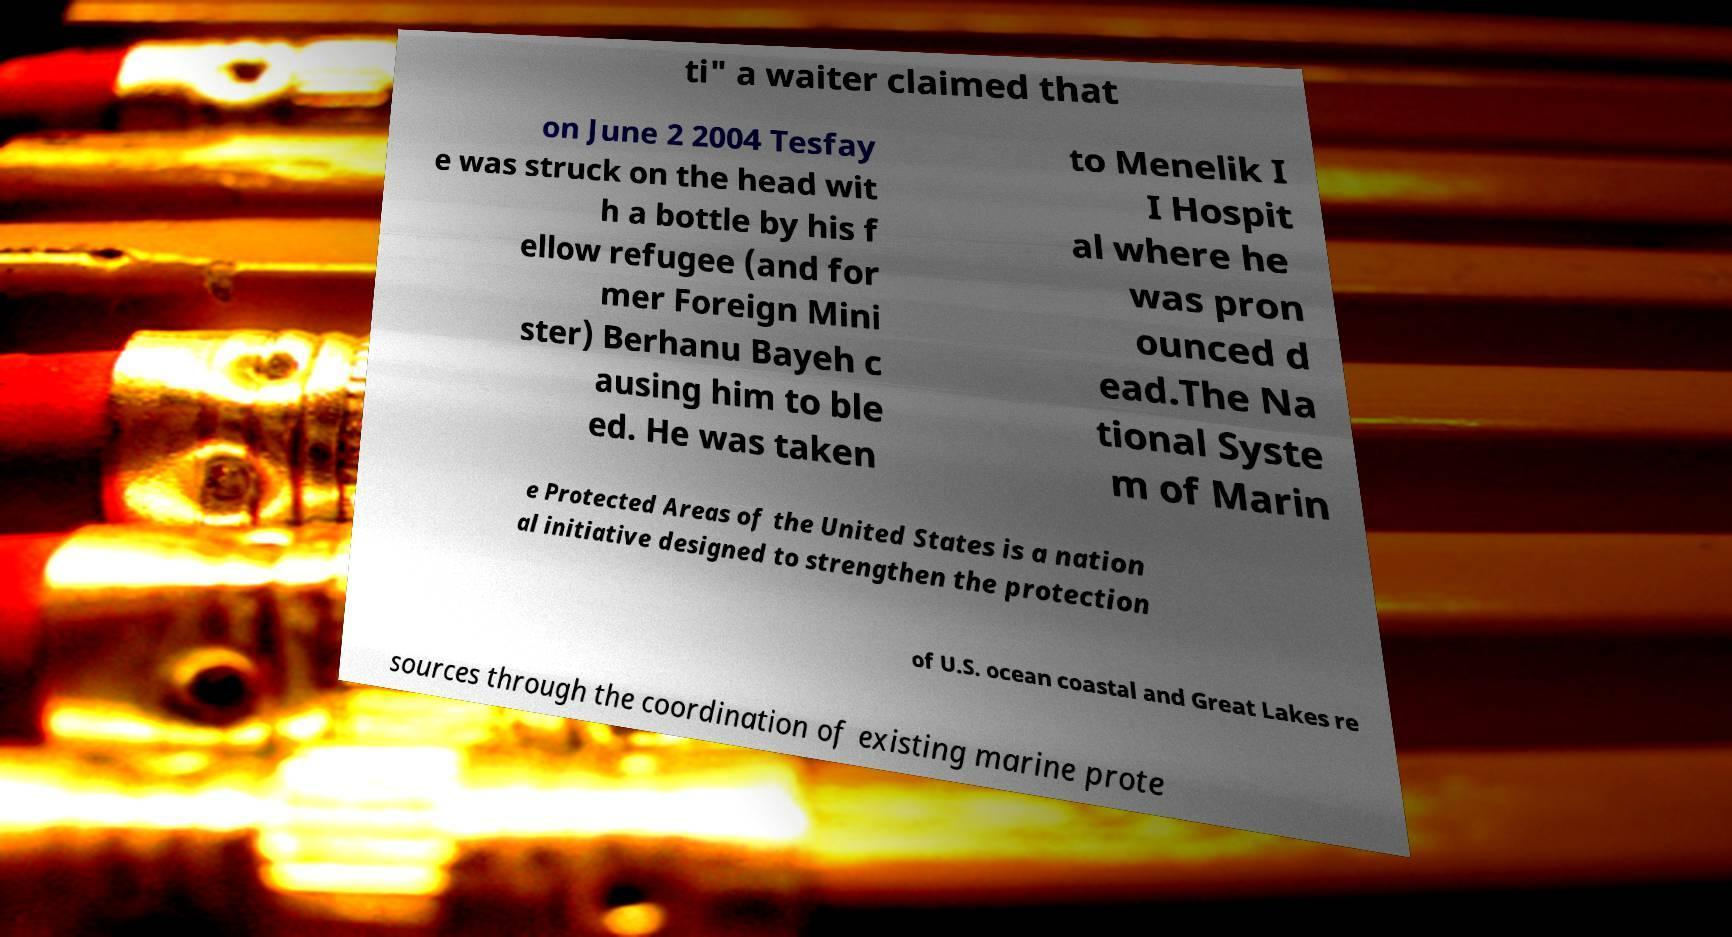Can you accurately transcribe the text from the provided image for me? ti" a waiter claimed that on June 2 2004 Tesfay e was struck on the head wit h a bottle by his f ellow refugee (and for mer Foreign Mini ster) Berhanu Bayeh c ausing him to ble ed. He was taken to Menelik I I Hospit al where he was pron ounced d ead.The Na tional Syste m of Marin e Protected Areas of the United States is a nation al initiative designed to strengthen the protection of U.S. ocean coastal and Great Lakes re sources through the coordination of existing marine prote 